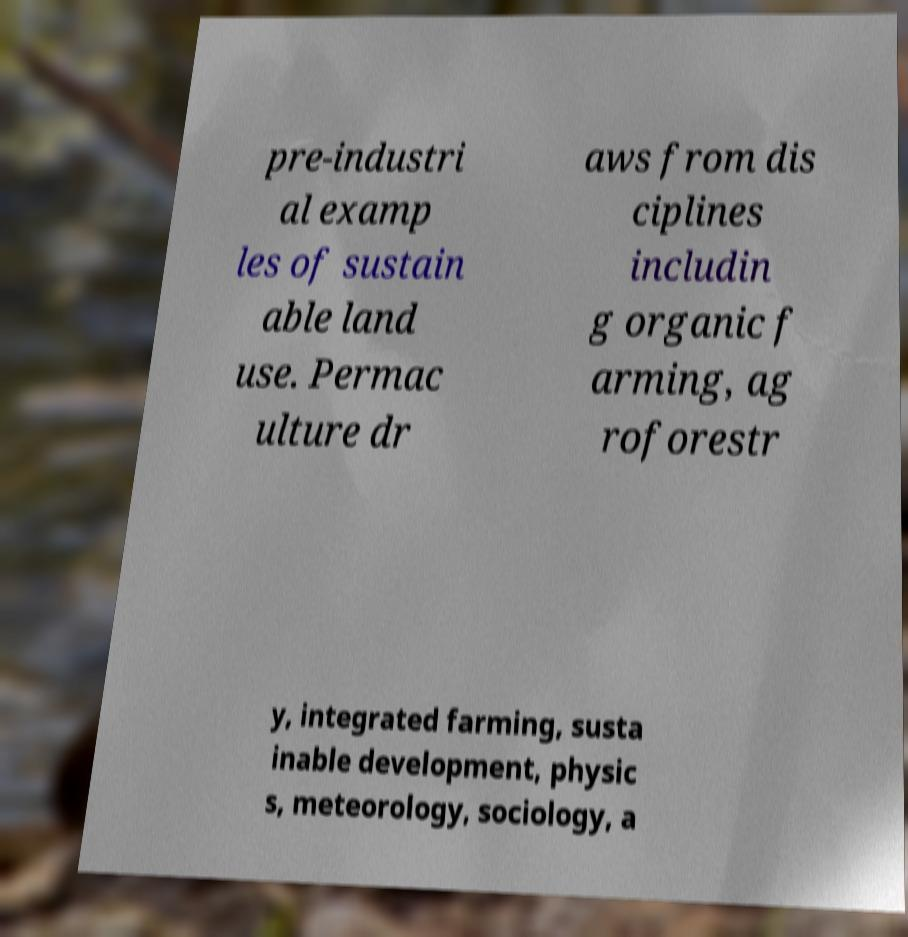For documentation purposes, I need the text within this image transcribed. Could you provide that? pre-industri al examp les of sustain able land use. Permac ulture dr aws from dis ciplines includin g organic f arming, ag roforestr y, integrated farming, susta inable development, physic s, meteorology, sociology, a 